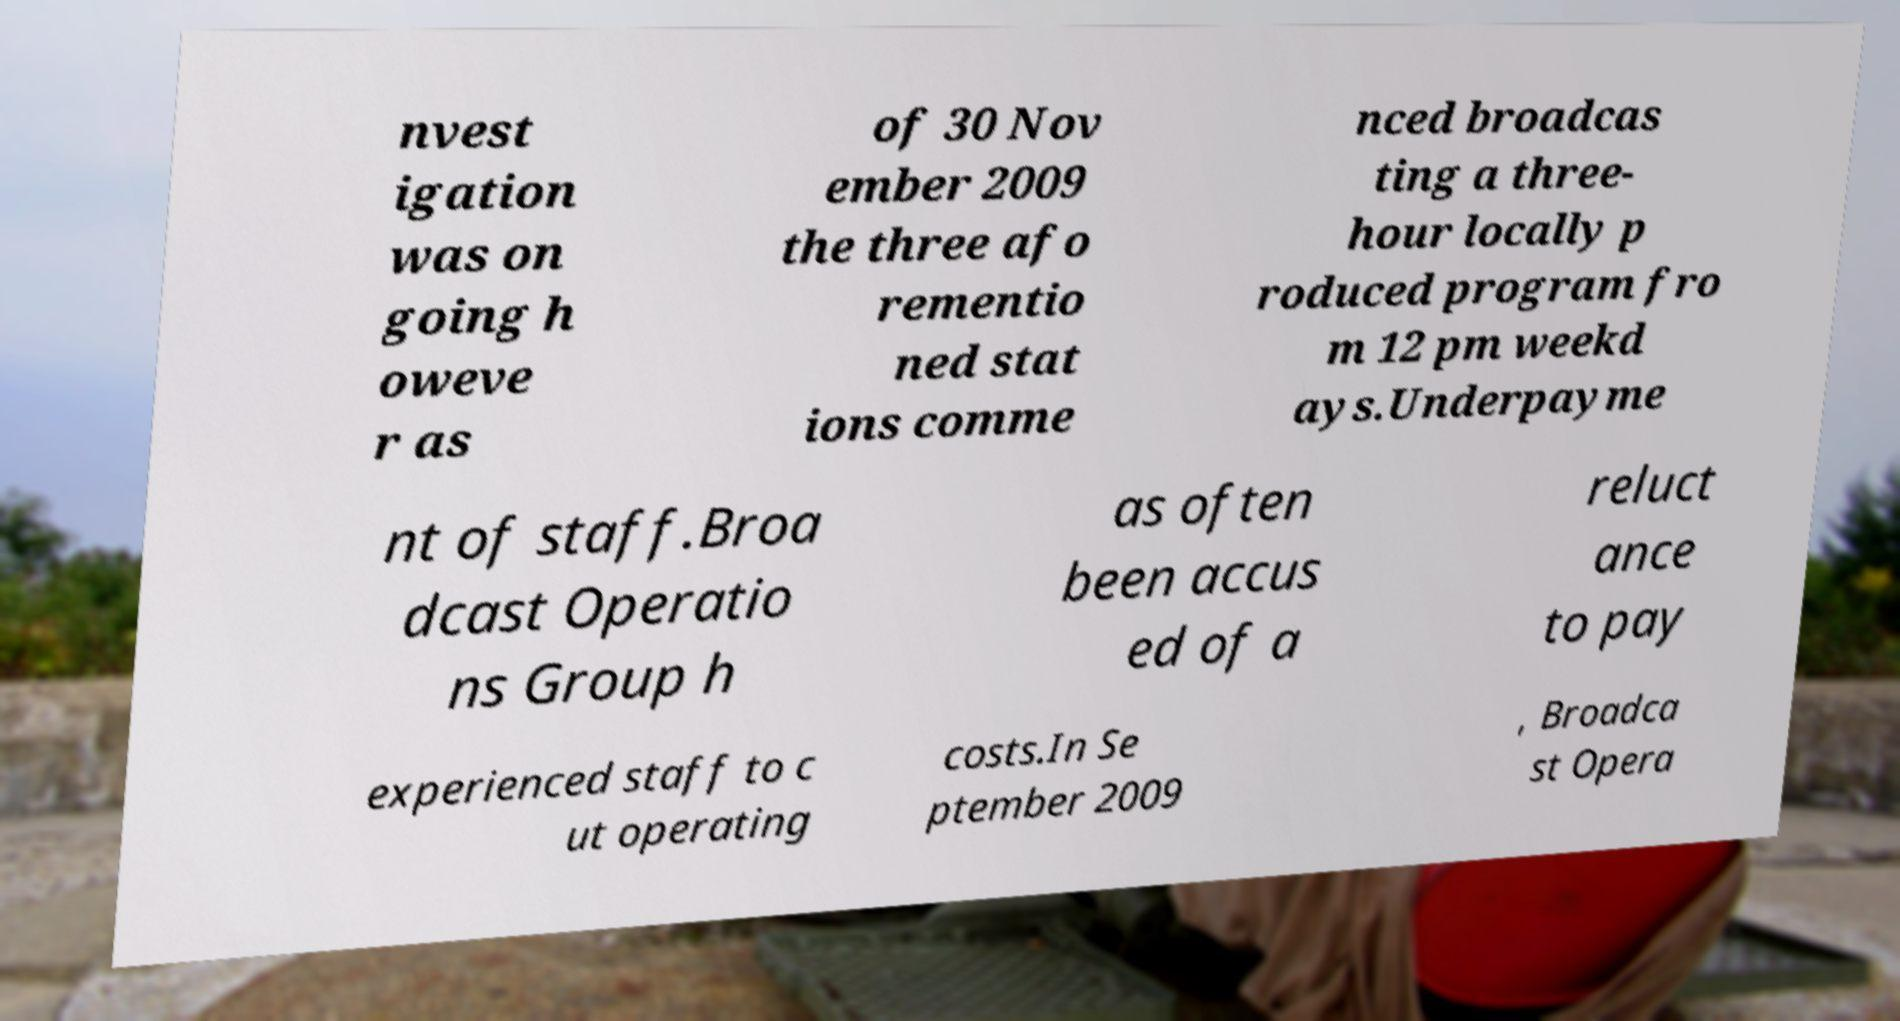Can you read and provide the text displayed in the image?This photo seems to have some interesting text. Can you extract and type it out for me? nvest igation was on going h oweve r as of 30 Nov ember 2009 the three afo rementio ned stat ions comme nced broadcas ting a three- hour locally p roduced program fro m 12 pm weekd ays.Underpayme nt of staff.Broa dcast Operatio ns Group h as often been accus ed of a reluct ance to pay experienced staff to c ut operating costs.In Se ptember 2009 , Broadca st Opera 